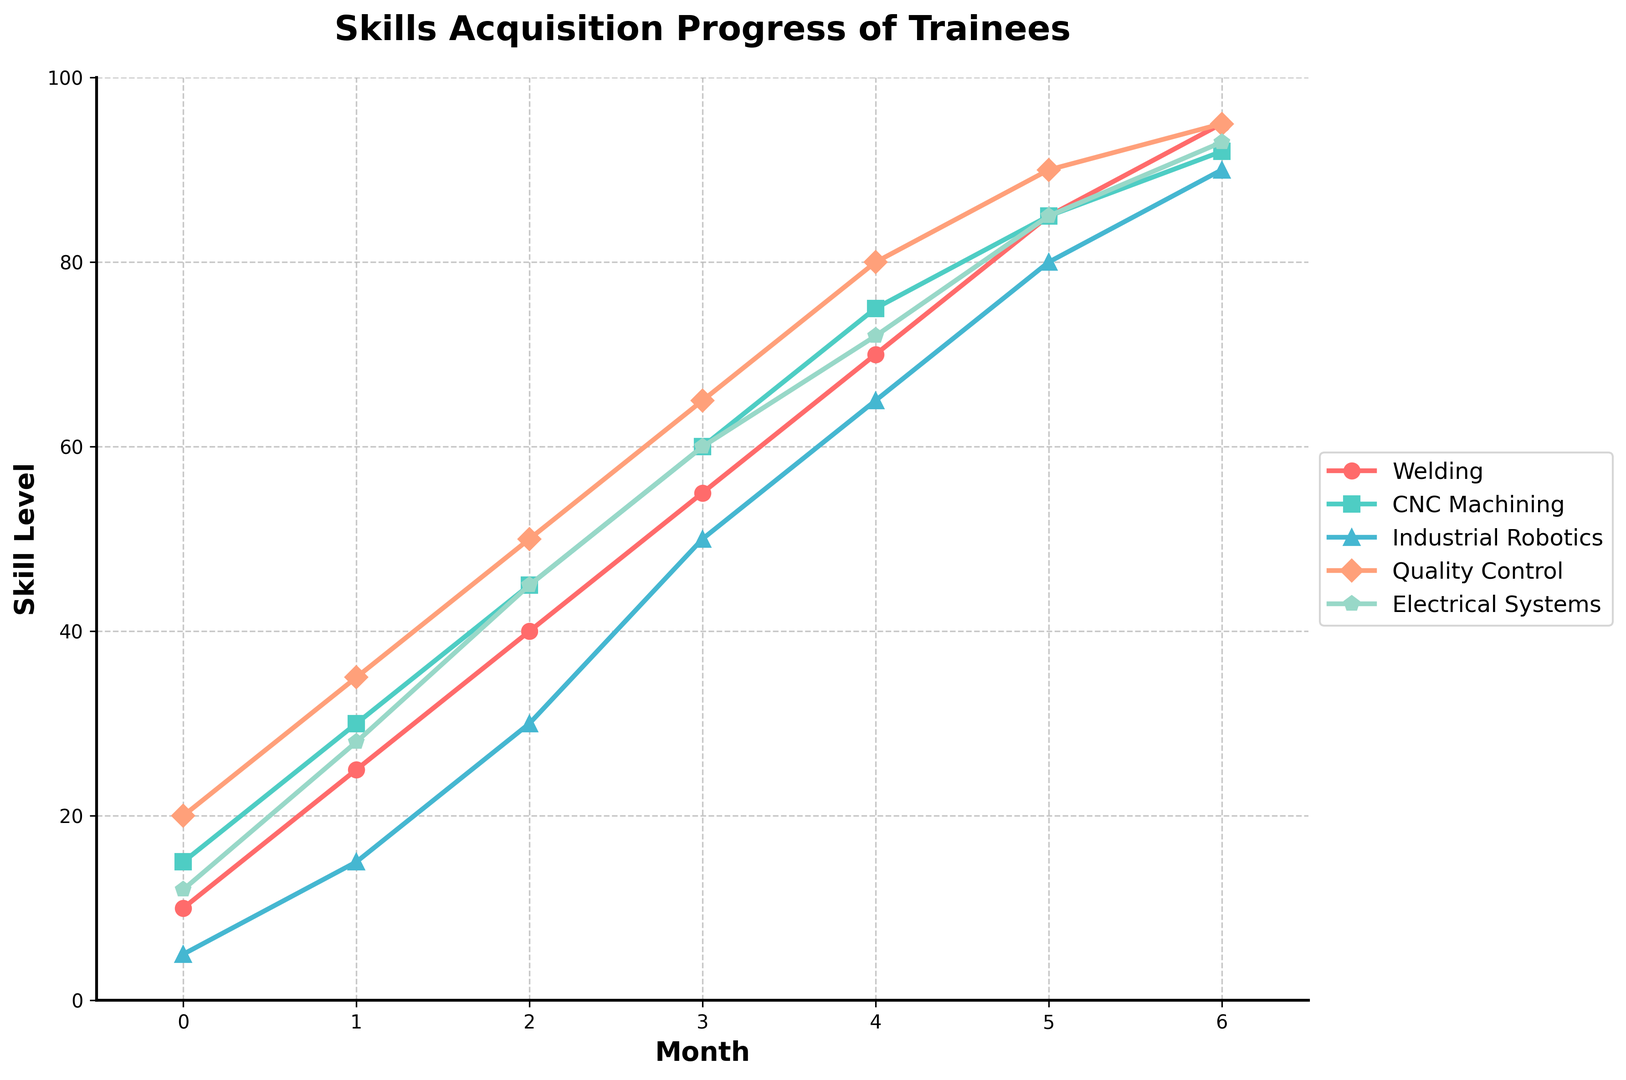Which skill sees the highest increase from month 0 to month 6? Identify the initial and final values for each skill. Welding goes from 10 to 95, CNC Machining from 15 to 92, Industrial Robotics from 5 to 90, Quality Control from 20 to 95, Electrical Systems from 12 to 93. Welding and Quality Control both increase by 85.
Answer: Welding, Quality Control What was the skill level of Industrial Robotics at month 4? Look at the value for Industrial Robotics at month 4 on the chart. The line corresponding to Industrial Robotics (blue line) is at 65.
Answer: 65 How much did the skill level of CNC Machining increase between month 3 and month 4? Find the values for CNC Machining at months 3 and 4. These values are 60 and 75, respectively. Subtract month 3 value from month 4 value: 75 - 60 = 15.
Answer: 15 Which two skills have the most similar skill levels at month 5? Evaluate the skill levels at month 5: Welding (85), CNC Machining (85), Industrial Robotics (80), Quality Control (90), Electrical Systems (85). Welding, CNC Machining, and Electrical Systems all have values of 85 and are hence the most similar.
Answer: Welding, CNC Machining, Electrical Systems Compare the skill levels of Quality Control and Electrical Systems at month 2. Which one is higher and by how much? Values at month 2: Quality Control is 50, Electrical Systems is 45. Subtract Electrical Systems value from Quality Control value: 50 - 45 = 5. Quality Control is higher.
Answer: Quality Control, 5 What is the average skill level for Welding from month 1 to month 5? Values: Welding at month 1 (25), month 2 (40), month 3 (55), month 4 (70), and month 5 (85). Sum these values: 25 + 40 + 55 + 70 + 85 = 275. Average is 275/5 = 55.
Answer: 55 Determine which skill had the highest skill level in month 6 and its value. Check the values at month 6: Welding (95), CNC Machining (92), Industrial Robotics (90), Quality Control (95), Electrical Systems (93). Welding and Quality Control both are highest at 95.
Answer: Welding, Quality Control, 95 How did the quality control skill level change from month 0 to month 3? Values: Quality Control at month 0 (20), month 3 (65). Subtract month 0 value from month 3 value: 65 - 20 = 45.
Answer: Increased by 45 Calculate the total skill level for Electrical Systems over the entire 6 months. Values: Month 0 (12), Month 1 (28), Month 2 (45), Month 3 (60), Month 4 (72), Month 5 (85), Month 6 (93). Sum these values: 12 + 28 + 45 + 60 + 72 + 85 + 93 = 395.
Answer: 395 